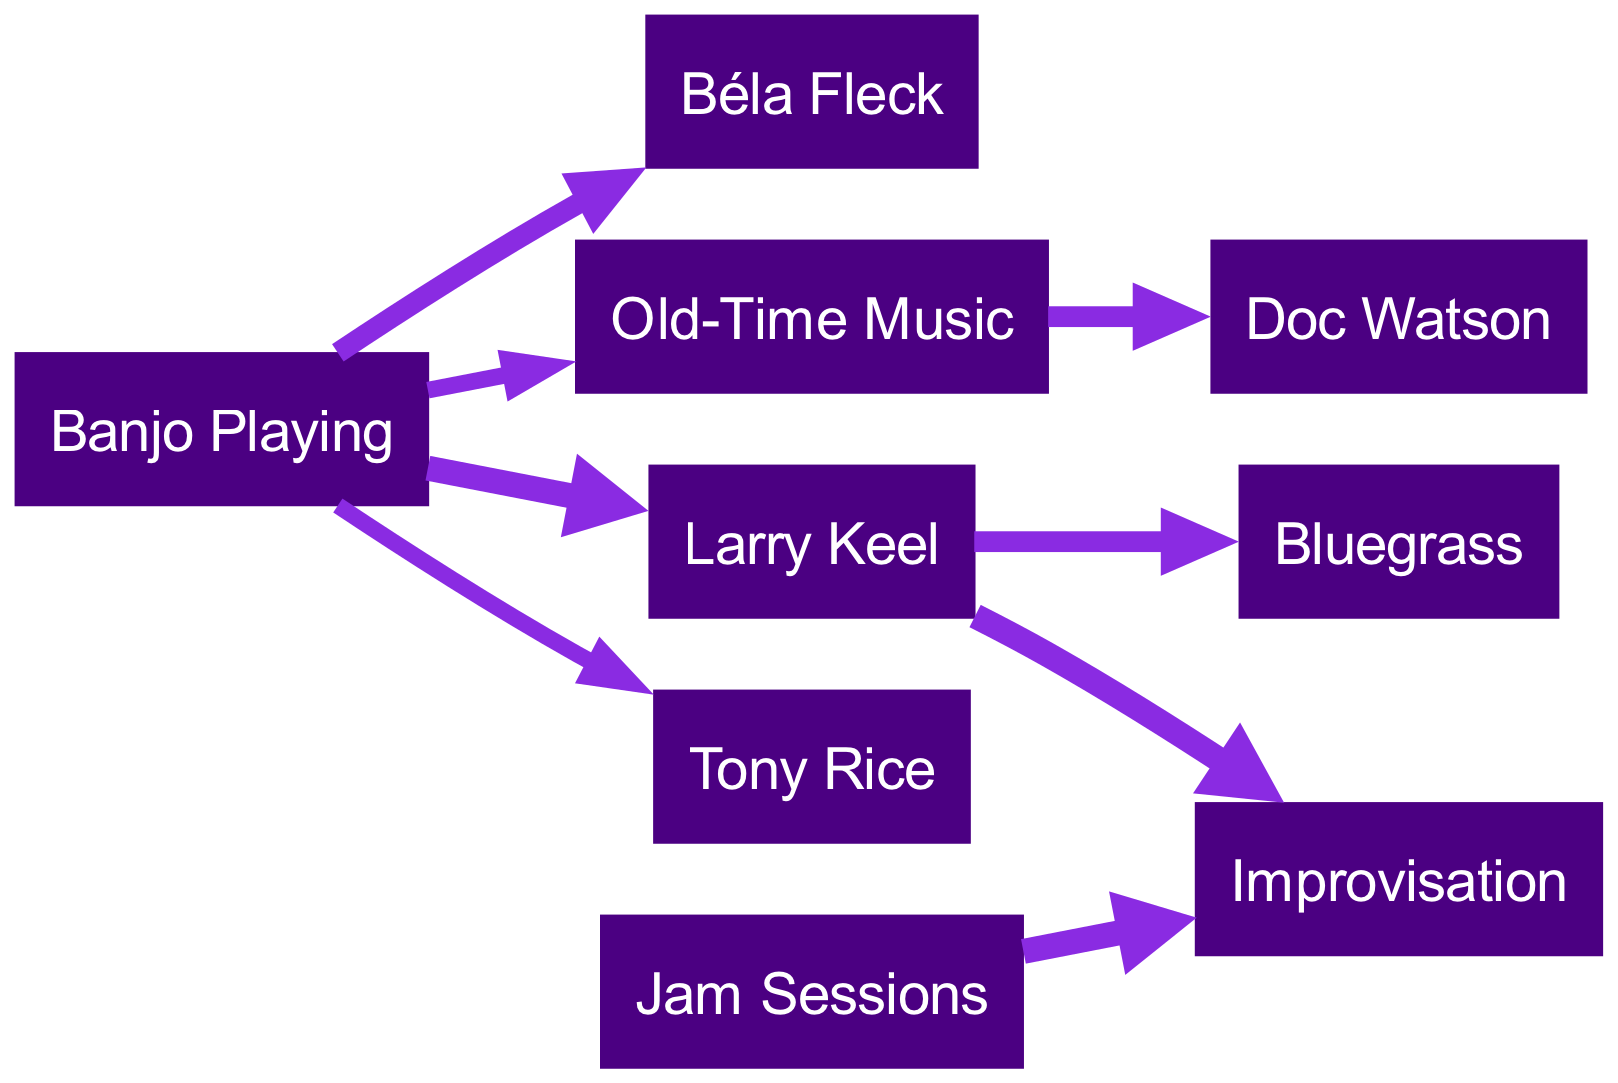What is the total number of nodes in the diagram? The diagram shows eight nodes: "Banjo Playing," "Larry Keel," "Bluegrass," "Old-Time Music," "Tony Rice," "Béla Fleck," "Doc Watson," "Improvisation," and "Jam Sessions." Counting each of these gives a total of eight nodes.
Answer: 8 What is the value of the connection between Banjo Playing and Larry Keel? The edge connecting "Banjo Playing" to "Larry Keel" has a value of 5, as indicated in the diagram data.
Answer: 5 Which artist is connected to Old-Time Music? "Old-Time Music" is connected to "Doc Watson" with a value of 4, as shown in the diagram.
Answer: Doc Watson How many influences does Larry Keel have in total? Larry Keel influences two direct categories, "Bluegrass" and "Improvisation," with corresponding values of 4 and 5. Therefore, summing these influences gives a total of two directly connected influences.
Answer: 2 Which node has the highest value connected to Banjo Playing? The highest value connection to "Banjo Playing" is with "Larry Keel" (value 5) and "Béla Fleck" (value 4). Comparing these values, "Larry Keel" has the highest connection value.
Answer: Larry Keel Determine the total flow from Jam Sessions. "Jam Sessions" connects only to "Improvisation" with a value of 5. As this is the only outgoing link, the total flow from "Jam Sessions" is simply this value.
Answer: 5 What type of music do Larry Keel's influences mainly fall under? Larry Keel is primarily connected to "Bluegrass" and "Improvisation," indicating that his influences largely fall under Bluegrass music.
Answer: Bluegrass Which source has the least connections in the diagram? "Tony Rice" connects only to "Banjo Playing" with a value of 3, representing the least number of connections among the nodes in the diagram.
Answer: Tony Rice 